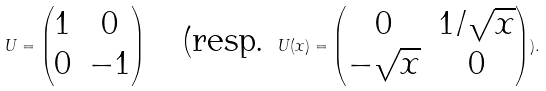<formula> <loc_0><loc_0><loc_500><loc_500>U = \begin{pmatrix} 1 & 0 \\ 0 & - 1 \end{pmatrix} \quad \text {(resp. } U ( x ) = \begin{pmatrix} 0 & 1 / \sqrt { x } \\ - \sqrt { x } & 0 \end{pmatrix} ) .</formula> 